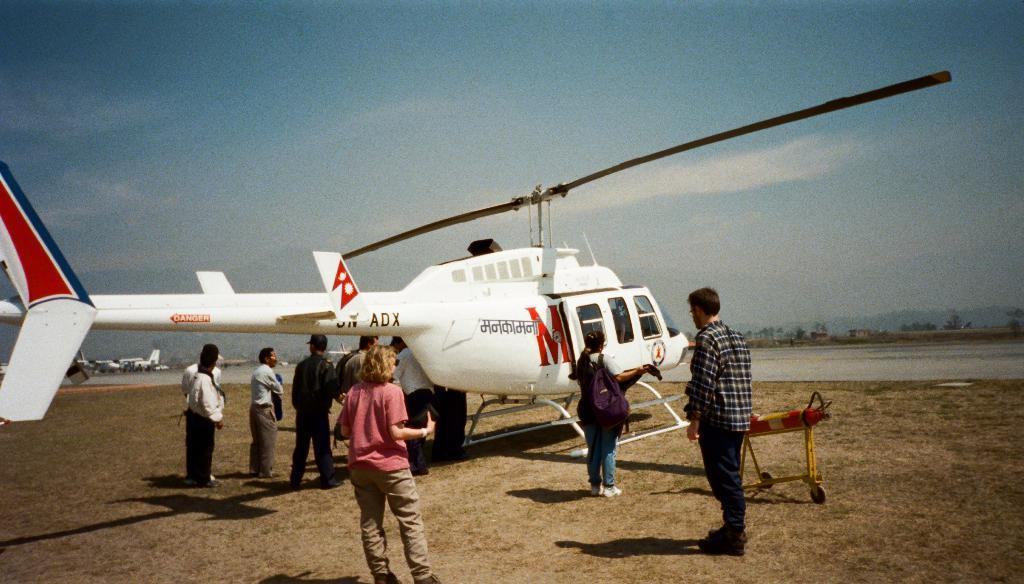<image>
Render a clear and concise summary of the photo. Many people are surrounding a white helicopter with a larg red M on it 